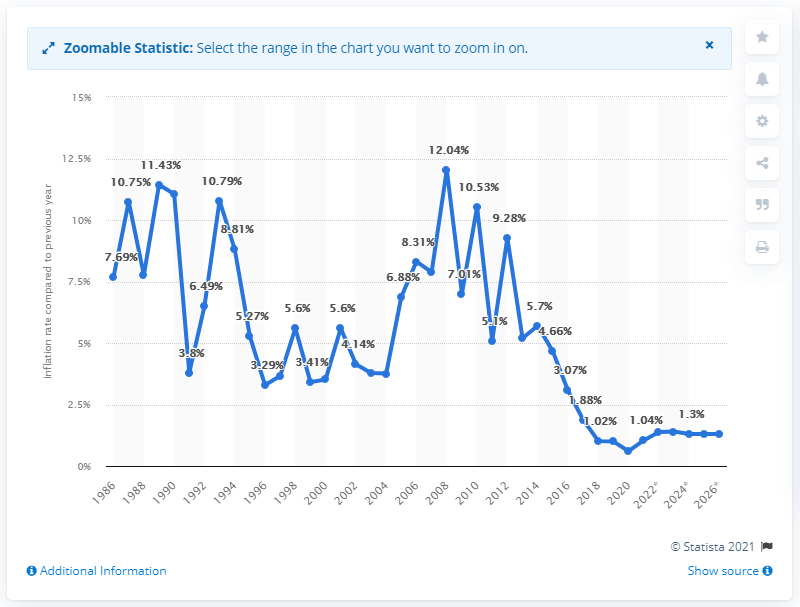Specify some key components in this picture. In 2020, the inflation rate in Trinidad and Tobago was 0.6%. 